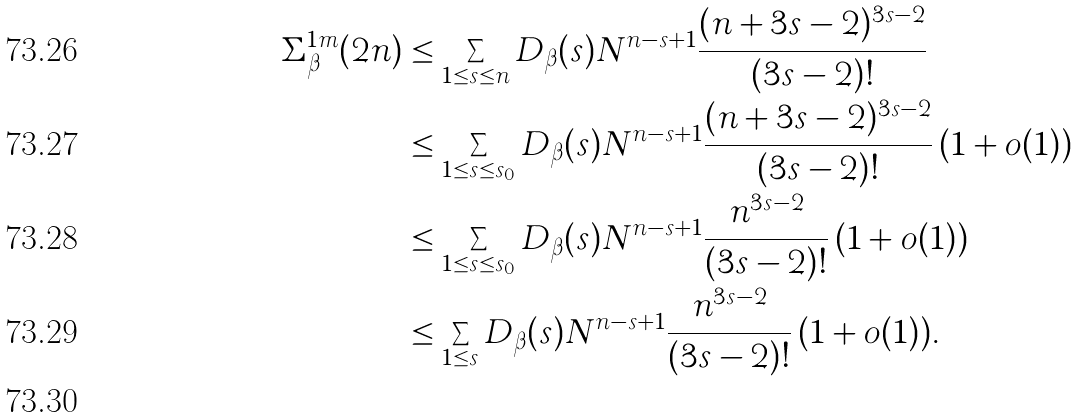Convert formula to latex. <formula><loc_0><loc_0><loc_500><loc_500>\Sigma ^ { 1 m } _ { \beta } ( 2 n ) & \leq \sum _ { 1 \leq s \leq n } D _ { \beta } ( s ) N ^ { n - s + 1 } \frac { ( n + 3 s - 2 ) ^ { 3 s - 2 } } { ( 3 s - 2 ) ! } \\ & \leq \sum _ { 1 \leq s \leq s _ { 0 } } D _ { \beta } ( s ) N ^ { n - s + 1 } \frac { ( n + 3 s - 2 ) ^ { 3 s - 2 } } { ( 3 s - 2 ) ! } \, ( 1 + o ( 1 ) ) \\ & \leq \sum _ { 1 \leq s \leq s _ { 0 } } D _ { \beta } ( s ) N ^ { n - s + 1 } \frac { n ^ { 3 s - 2 } } { ( 3 s - 2 ) ! } \, ( 1 + o ( 1 ) ) \\ & \leq \sum _ { 1 \leq s } D _ { \beta } ( s ) N ^ { n - s + 1 } \frac { n ^ { 3 s - 2 } } { ( 3 s - 2 ) ! } \, ( 1 + o ( 1 ) ) . \\</formula> 